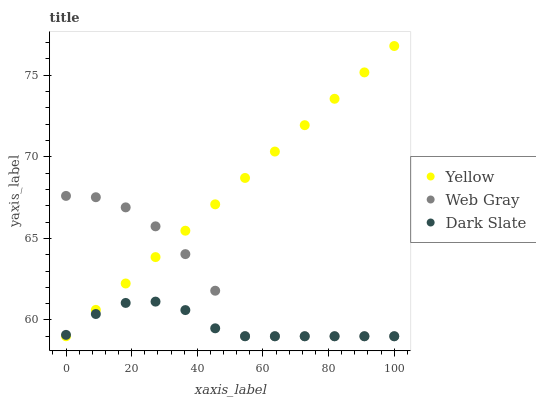Does Dark Slate have the minimum area under the curve?
Answer yes or no. Yes. Does Yellow have the maximum area under the curve?
Answer yes or no. Yes. Does Web Gray have the minimum area under the curve?
Answer yes or no. No. Does Web Gray have the maximum area under the curve?
Answer yes or no. No. Is Yellow the smoothest?
Answer yes or no. Yes. Is Web Gray the roughest?
Answer yes or no. Yes. Is Web Gray the smoothest?
Answer yes or no. No. Is Yellow the roughest?
Answer yes or no. No. Does Dark Slate have the lowest value?
Answer yes or no. Yes. Does Yellow have the highest value?
Answer yes or no. Yes. Does Web Gray have the highest value?
Answer yes or no. No. Does Web Gray intersect Yellow?
Answer yes or no. Yes. Is Web Gray less than Yellow?
Answer yes or no. No. Is Web Gray greater than Yellow?
Answer yes or no. No. 